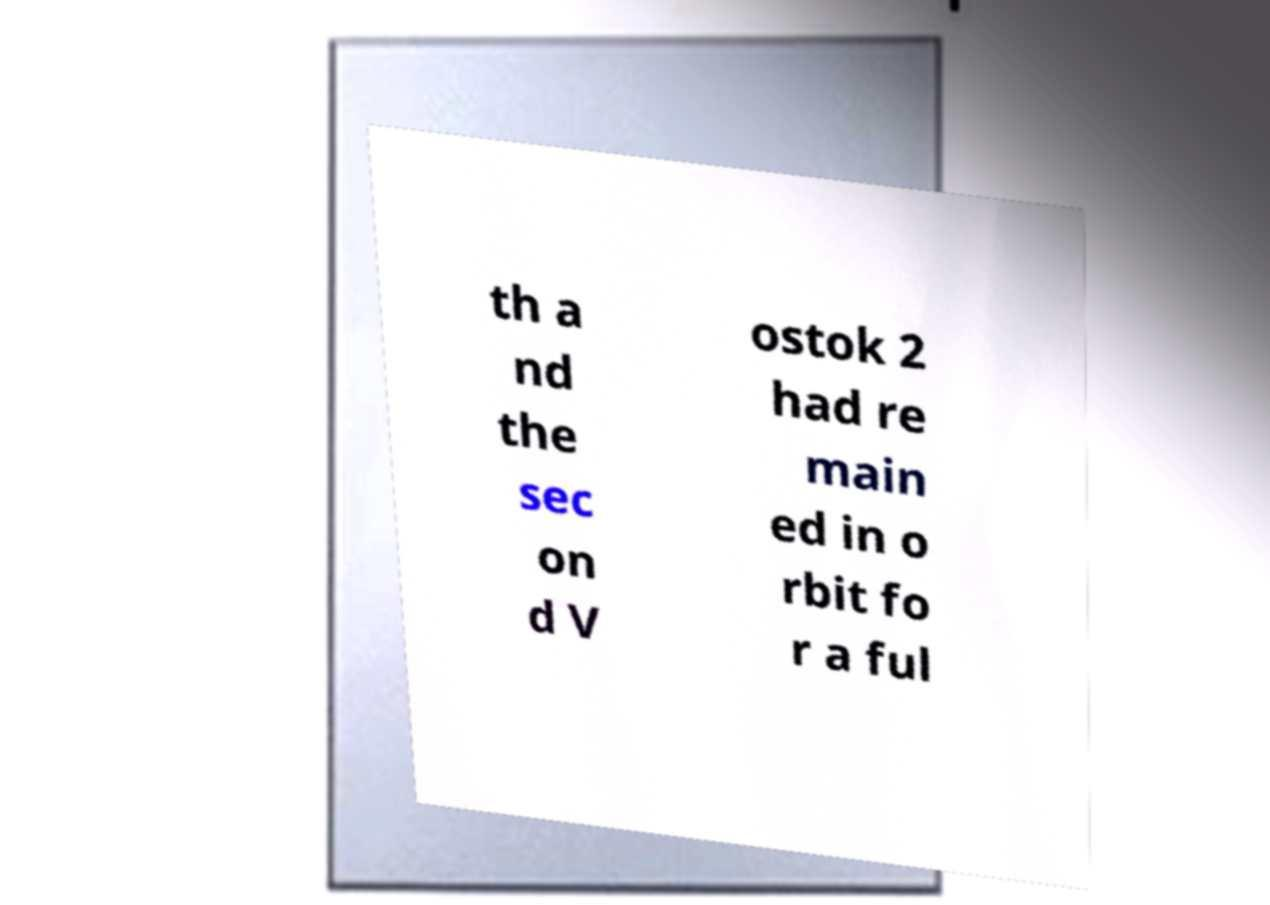Could you extract and type out the text from this image? th a nd the sec on d V ostok 2 had re main ed in o rbit fo r a ful 